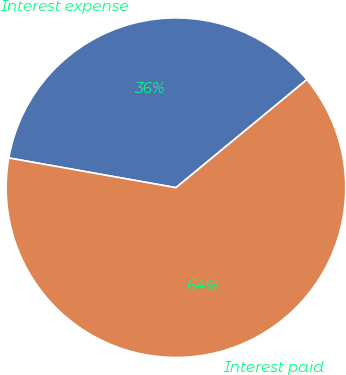Convert chart to OTSL. <chart><loc_0><loc_0><loc_500><loc_500><pie_chart><fcel>Interest expense<fcel>Interest paid<nl><fcel>36.22%<fcel>63.78%<nl></chart> 